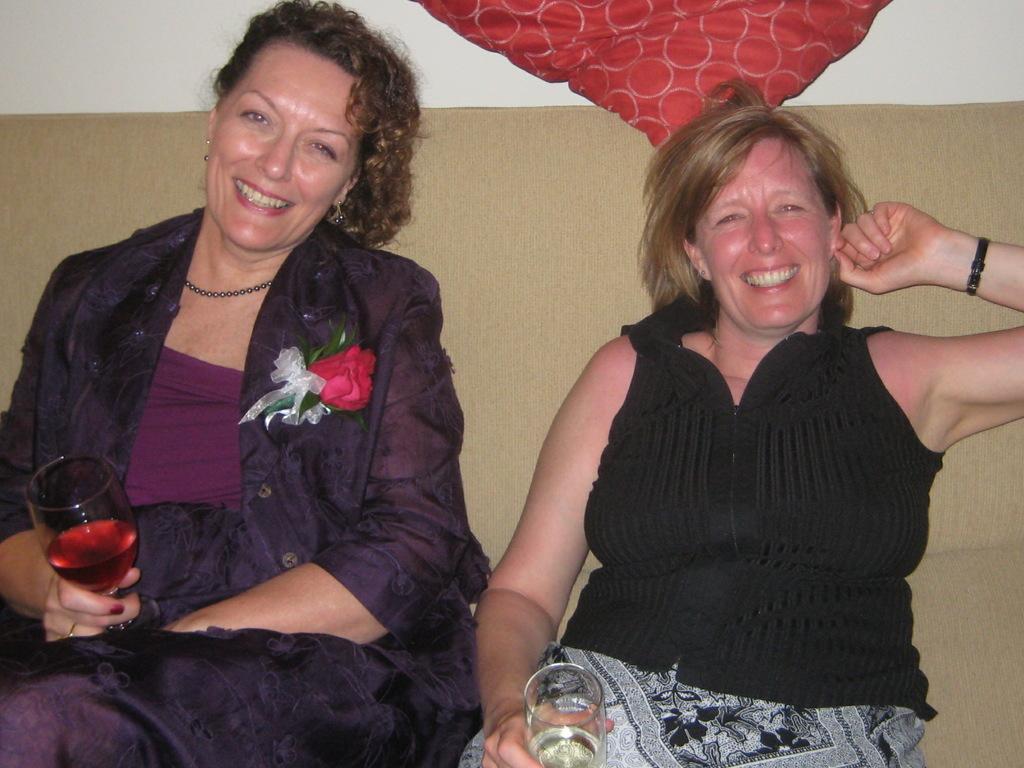Could you give a brief overview of what you see in this image? This two women are sitting on a couch. This woman holds smile and glass with liquid. This woman holds smile and wore black dress. On this woman jacket there is a flower. 